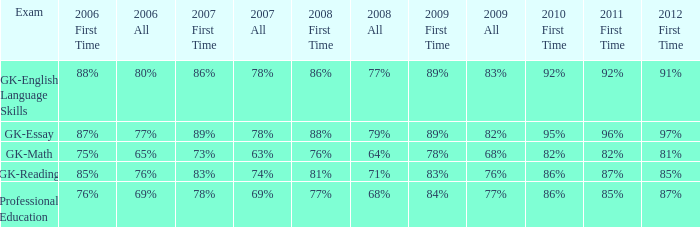What is the proportion for the entire 2008 when the total for 2007 is 69%? 68%. 